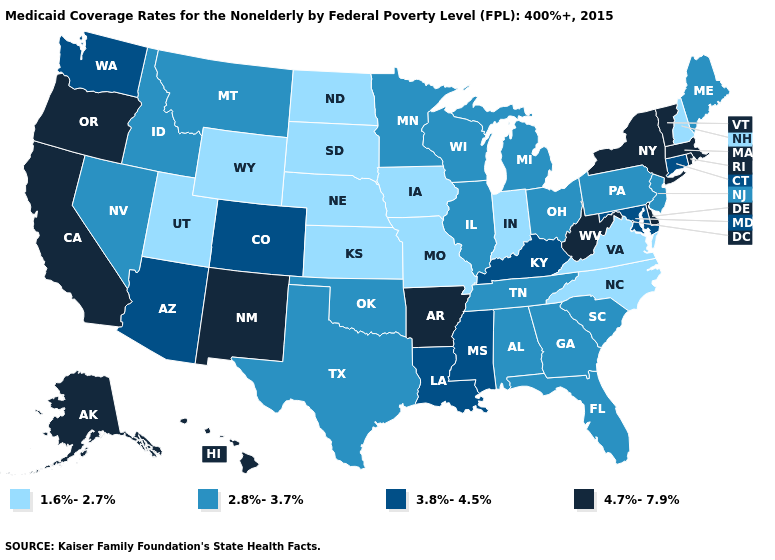Among the states that border Arkansas , does Texas have the highest value?
Concise answer only. No. Does Washington have a higher value than Florida?
Answer briefly. Yes. Does Arkansas have the highest value in the USA?
Write a very short answer. Yes. What is the value of Utah?
Be succinct. 1.6%-2.7%. Which states have the lowest value in the MidWest?
Quick response, please. Indiana, Iowa, Kansas, Missouri, Nebraska, North Dakota, South Dakota. Name the states that have a value in the range 1.6%-2.7%?
Keep it brief. Indiana, Iowa, Kansas, Missouri, Nebraska, New Hampshire, North Carolina, North Dakota, South Dakota, Utah, Virginia, Wyoming. What is the highest value in the South ?
Keep it brief. 4.7%-7.9%. Does Missouri have a lower value than West Virginia?
Be succinct. Yes. What is the value of Massachusetts?
Be succinct. 4.7%-7.9%. Among the states that border Indiana , which have the lowest value?
Be succinct. Illinois, Michigan, Ohio. Which states have the highest value in the USA?
Write a very short answer. Alaska, Arkansas, California, Delaware, Hawaii, Massachusetts, New Mexico, New York, Oregon, Rhode Island, Vermont, West Virginia. Name the states that have a value in the range 2.8%-3.7%?
Quick response, please. Alabama, Florida, Georgia, Idaho, Illinois, Maine, Michigan, Minnesota, Montana, Nevada, New Jersey, Ohio, Oklahoma, Pennsylvania, South Carolina, Tennessee, Texas, Wisconsin. Among the states that border North Dakota , does Montana have the highest value?
Write a very short answer. Yes. Among the states that border Oklahoma , which have the lowest value?
Give a very brief answer. Kansas, Missouri. What is the highest value in the USA?
Short answer required. 4.7%-7.9%. 